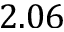<formula> <loc_0><loc_0><loc_500><loc_500>2 . 0 6</formula> 